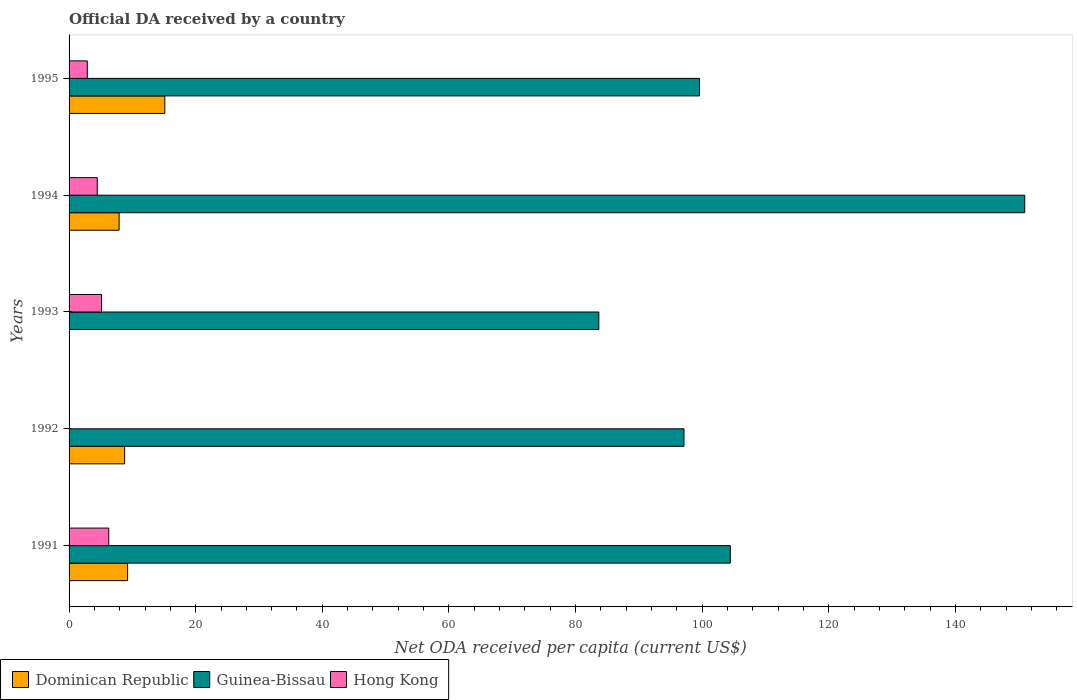How many groups of bars are there?
Your answer should be compact. 5. Are the number of bars on each tick of the Y-axis equal?
Give a very brief answer. No. What is the label of the 4th group of bars from the top?
Provide a short and direct response. 1992. In how many cases, is the number of bars for a given year not equal to the number of legend labels?
Offer a very short reply. 2. What is the ODA received in in Hong Kong in 1993?
Ensure brevity in your answer.  5.13. Across all years, what is the maximum ODA received in in Hong Kong?
Your answer should be very brief. 6.27. In which year was the ODA received in in Dominican Republic maximum?
Ensure brevity in your answer.  1995. What is the total ODA received in in Guinea-Bissau in the graph?
Provide a short and direct response. 535.78. What is the difference between the ODA received in in Dominican Republic in 1992 and that in 1995?
Keep it short and to the point. -6.34. What is the difference between the ODA received in in Hong Kong in 1992 and the ODA received in in Guinea-Bissau in 1993?
Offer a terse response. -83.68. What is the average ODA received in in Guinea-Bissau per year?
Keep it short and to the point. 107.16. In the year 1991, what is the difference between the ODA received in in Guinea-Bissau and ODA received in in Dominican Republic?
Give a very brief answer. 95.2. In how many years, is the ODA received in in Dominican Republic greater than 132 US$?
Ensure brevity in your answer.  0. What is the ratio of the ODA received in in Guinea-Bissau in 1992 to that in 1995?
Your answer should be very brief. 0.98. Is the ODA received in in Hong Kong in 1991 less than that in 1993?
Your answer should be compact. No. Is the difference between the ODA received in in Guinea-Bissau in 1994 and 1995 greater than the difference between the ODA received in in Dominican Republic in 1994 and 1995?
Give a very brief answer. Yes. What is the difference between the highest and the second highest ODA received in in Dominican Republic?
Give a very brief answer. 5.88. What is the difference between the highest and the lowest ODA received in in Dominican Republic?
Keep it short and to the point. 15.12. Is the sum of the ODA received in in Hong Kong in 1991 and 1995 greater than the maximum ODA received in in Guinea-Bissau across all years?
Offer a terse response. No. Where does the legend appear in the graph?
Provide a succinct answer. Bottom left. What is the title of the graph?
Provide a succinct answer. Official DA received by a country. Does "Pacific island small states" appear as one of the legend labels in the graph?
Your response must be concise. No. What is the label or title of the X-axis?
Your answer should be compact. Net ODA received per capita (current US$). What is the label or title of the Y-axis?
Keep it short and to the point. Years. What is the Net ODA received per capita (current US$) in Dominican Republic in 1991?
Provide a succinct answer. 9.24. What is the Net ODA received per capita (current US$) of Guinea-Bissau in 1991?
Make the answer very short. 104.44. What is the Net ODA received per capita (current US$) of Hong Kong in 1991?
Offer a very short reply. 6.27. What is the Net ODA received per capita (current US$) in Dominican Republic in 1992?
Provide a succinct answer. 8.78. What is the Net ODA received per capita (current US$) of Guinea-Bissau in 1992?
Make the answer very short. 97.13. What is the Net ODA received per capita (current US$) in Dominican Republic in 1993?
Your answer should be compact. 0. What is the Net ODA received per capita (current US$) of Guinea-Bissau in 1993?
Offer a terse response. 83.68. What is the Net ODA received per capita (current US$) of Hong Kong in 1993?
Keep it short and to the point. 5.13. What is the Net ODA received per capita (current US$) in Dominican Republic in 1994?
Provide a short and direct response. 7.9. What is the Net ODA received per capita (current US$) of Guinea-Bissau in 1994?
Keep it short and to the point. 150.95. What is the Net ODA received per capita (current US$) of Hong Kong in 1994?
Your response must be concise. 4.45. What is the Net ODA received per capita (current US$) in Dominican Republic in 1995?
Provide a succinct answer. 15.12. What is the Net ODA received per capita (current US$) in Guinea-Bissau in 1995?
Ensure brevity in your answer.  99.59. What is the Net ODA received per capita (current US$) in Hong Kong in 1995?
Your answer should be compact. 2.88. Across all years, what is the maximum Net ODA received per capita (current US$) of Dominican Republic?
Give a very brief answer. 15.12. Across all years, what is the maximum Net ODA received per capita (current US$) in Guinea-Bissau?
Ensure brevity in your answer.  150.95. Across all years, what is the maximum Net ODA received per capita (current US$) of Hong Kong?
Your answer should be very brief. 6.27. Across all years, what is the minimum Net ODA received per capita (current US$) of Guinea-Bissau?
Give a very brief answer. 83.68. What is the total Net ODA received per capita (current US$) in Dominican Republic in the graph?
Offer a terse response. 41.05. What is the total Net ODA received per capita (current US$) in Guinea-Bissau in the graph?
Your answer should be very brief. 535.78. What is the total Net ODA received per capita (current US$) in Hong Kong in the graph?
Ensure brevity in your answer.  18.73. What is the difference between the Net ODA received per capita (current US$) of Dominican Republic in 1991 and that in 1992?
Give a very brief answer. 0.46. What is the difference between the Net ODA received per capita (current US$) in Guinea-Bissau in 1991 and that in 1992?
Keep it short and to the point. 7.31. What is the difference between the Net ODA received per capita (current US$) in Guinea-Bissau in 1991 and that in 1993?
Make the answer very short. 20.77. What is the difference between the Net ODA received per capita (current US$) of Hong Kong in 1991 and that in 1993?
Offer a terse response. 1.14. What is the difference between the Net ODA received per capita (current US$) in Dominican Republic in 1991 and that in 1994?
Give a very brief answer. 1.34. What is the difference between the Net ODA received per capita (current US$) in Guinea-Bissau in 1991 and that in 1994?
Your answer should be very brief. -46.5. What is the difference between the Net ODA received per capita (current US$) in Hong Kong in 1991 and that in 1994?
Offer a terse response. 1.82. What is the difference between the Net ODA received per capita (current US$) in Dominican Republic in 1991 and that in 1995?
Keep it short and to the point. -5.88. What is the difference between the Net ODA received per capita (current US$) in Guinea-Bissau in 1991 and that in 1995?
Keep it short and to the point. 4.86. What is the difference between the Net ODA received per capita (current US$) in Hong Kong in 1991 and that in 1995?
Keep it short and to the point. 3.39. What is the difference between the Net ODA received per capita (current US$) of Guinea-Bissau in 1992 and that in 1993?
Your answer should be compact. 13.45. What is the difference between the Net ODA received per capita (current US$) of Dominican Republic in 1992 and that in 1994?
Keep it short and to the point. 0.88. What is the difference between the Net ODA received per capita (current US$) in Guinea-Bissau in 1992 and that in 1994?
Make the answer very short. -53.82. What is the difference between the Net ODA received per capita (current US$) in Dominican Republic in 1992 and that in 1995?
Make the answer very short. -6.34. What is the difference between the Net ODA received per capita (current US$) in Guinea-Bissau in 1992 and that in 1995?
Offer a very short reply. -2.46. What is the difference between the Net ODA received per capita (current US$) in Guinea-Bissau in 1993 and that in 1994?
Provide a succinct answer. -67.27. What is the difference between the Net ODA received per capita (current US$) of Hong Kong in 1993 and that in 1994?
Provide a succinct answer. 0.68. What is the difference between the Net ODA received per capita (current US$) in Guinea-Bissau in 1993 and that in 1995?
Your answer should be very brief. -15.91. What is the difference between the Net ODA received per capita (current US$) in Hong Kong in 1993 and that in 1995?
Provide a succinct answer. 2.25. What is the difference between the Net ODA received per capita (current US$) in Dominican Republic in 1994 and that in 1995?
Your response must be concise. -7.22. What is the difference between the Net ODA received per capita (current US$) in Guinea-Bissau in 1994 and that in 1995?
Keep it short and to the point. 51.36. What is the difference between the Net ODA received per capita (current US$) of Hong Kong in 1994 and that in 1995?
Your answer should be compact. 1.57. What is the difference between the Net ODA received per capita (current US$) of Dominican Republic in 1991 and the Net ODA received per capita (current US$) of Guinea-Bissau in 1992?
Ensure brevity in your answer.  -87.89. What is the difference between the Net ODA received per capita (current US$) in Dominican Republic in 1991 and the Net ODA received per capita (current US$) in Guinea-Bissau in 1993?
Offer a terse response. -74.43. What is the difference between the Net ODA received per capita (current US$) in Dominican Republic in 1991 and the Net ODA received per capita (current US$) in Hong Kong in 1993?
Make the answer very short. 4.11. What is the difference between the Net ODA received per capita (current US$) in Guinea-Bissau in 1991 and the Net ODA received per capita (current US$) in Hong Kong in 1993?
Ensure brevity in your answer.  99.31. What is the difference between the Net ODA received per capita (current US$) of Dominican Republic in 1991 and the Net ODA received per capita (current US$) of Guinea-Bissau in 1994?
Your answer should be very brief. -141.7. What is the difference between the Net ODA received per capita (current US$) in Dominican Republic in 1991 and the Net ODA received per capita (current US$) in Hong Kong in 1994?
Your response must be concise. 4.79. What is the difference between the Net ODA received per capita (current US$) of Guinea-Bissau in 1991 and the Net ODA received per capita (current US$) of Hong Kong in 1994?
Offer a very short reply. 99.99. What is the difference between the Net ODA received per capita (current US$) in Dominican Republic in 1991 and the Net ODA received per capita (current US$) in Guinea-Bissau in 1995?
Ensure brevity in your answer.  -90.34. What is the difference between the Net ODA received per capita (current US$) in Dominican Republic in 1991 and the Net ODA received per capita (current US$) in Hong Kong in 1995?
Your answer should be very brief. 6.36. What is the difference between the Net ODA received per capita (current US$) in Guinea-Bissau in 1991 and the Net ODA received per capita (current US$) in Hong Kong in 1995?
Your response must be concise. 101.56. What is the difference between the Net ODA received per capita (current US$) of Dominican Republic in 1992 and the Net ODA received per capita (current US$) of Guinea-Bissau in 1993?
Keep it short and to the point. -74.9. What is the difference between the Net ODA received per capita (current US$) in Dominican Republic in 1992 and the Net ODA received per capita (current US$) in Hong Kong in 1993?
Make the answer very short. 3.65. What is the difference between the Net ODA received per capita (current US$) of Guinea-Bissau in 1992 and the Net ODA received per capita (current US$) of Hong Kong in 1993?
Keep it short and to the point. 92. What is the difference between the Net ODA received per capita (current US$) in Dominican Republic in 1992 and the Net ODA received per capita (current US$) in Guinea-Bissau in 1994?
Your answer should be compact. -142.17. What is the difference between the Net ODA received per capita (current US$) in Dominican Republic in 1992 and the Net ODA received per capita (current US$) in Hong Kong in 1994?
Provide a succinct answer. 4.33. What is the difference between the Net ODA received per capita (current US$) of Guinea-Bissau in 1992 and the Net ODA received per capita (current US$) of Hong Kong in 1994?
Provide a succinct answer. 92.68. What is the difference between the Net ODA received per capita (current US$) of Dominican Republic in 1992 and the Net ODA received per capita (current US$) of Guinea-Bissau in 1995?
Ensure brevity in your answer.  -90.81. What is the difference between the Net ODA received per capita (current US$) in Dominican Republic in 1992 and the Net ODA received per capita (current US$) in Hong Kong in 1995?
Offer a terse response. 5.9. What is the difference between the Net ODA received per capita (current US$) of Guinea-Bissau in 1992 and the Net ODA received per capita (current US$) of Hong Kong in 1995?
Ensure brevity in your answer.  94.25. What is the difference between the Net ODA received per capita (current US$) in Guinea-Bissau in 1993 and the Net ODA received per capita (current US$) in Hong Kong in 1994?
Give a very brief answer. 79.22. What is the difference between the Net ODA received per capita (current US$) in Guinea-Bissau in 1993 and the Net ODA received per capita (current US$) in Hong Kong in 1995?
Offer a very short reply. 80.8. What is the difference between the Net ODA received per capita (current US$) of Dominican Republic in 1994 and the Net ODA received per capita (current US$) of Guinea-Bissau in 1995?
Offer a very short reply. -91.68. What is the difference between the Net ODA received per capita (current US$) of Dominican Republic in 1994 and the Net ODA received per capita (current US$) of Hong Kong in 1995?
Offer a very short reply. 5.02. What is the difference between the Net ODA received per capita (current US$) in Guinea-Bissau in 1994 and the Net ODA received per capita (current US$) in Hong Kong in 1995?
Your answer should be very brief. 148.07. What is the average Net ODA received per capita (current US$) of Dominican Republic per year?
Your answer should be very brief. 8.21. What is the average Net ODA received per capita (current US$) of Guinea-Bissau per year?
Provide a succinct answer. 107.16. What is the average Net ODA received per capita (current US$) of Hong Kong per year?
Your answer should be very brief. 3.75. In the year 1991, what is the difference between the Net ODA received per capita (current US$) in Dominican Republic and Net ODA received per capita (current US$) in Guinea-Bissau?
Ensure brevity in your answer.  -95.2. In the year 1991, what is the difference between the Net ODA received per capita (current US$) of Dominican Republic and Net ODA received per capita (current US$) of Hong Kong?
Keep it short and to the point. 2.97. In the year 1991, what is the difference between the Net ODA received per capita (current US$) of Guinea-Bissau and Net ODA received per capita (current US$) of Hong Kong?
Offer a very short reply. 98.17. In the year 1992, what is the difference between the Net ODA received per capita (current US$) in Dominican Republic and Net ODA received per capita (current US$) in Guinea-Bissau?
Your answer should be very brief. -88.35. In the year 1993, what is the difference between the Net ODA received per capita (current US$) of Guinea-Bissau and Net ODA received per capita (current US$) of Hong Kong?
Make the answer very short. 78.55. In the year 1994, what is the difference between the Net ODA received per capita (current US$) of Dominican Republic and Net ODA received per capita (current US$) of Guinea-Bissau?
Your answer should be very brief. -143.04. In the year 1994, what is the difference between the Net ODA received per capita (current US$) of Dominican Republic and Net ODA received per capita (current US$) of Hong Kong?
Provide a succinct answer. 3.45. In the year 1994, what is the difference between the Net ODA received per capita (current US$) of Guinea-Bissau and Net ODA received per capita (current US$) of Hong Kong?
Offer a very short reply. 146.49. In the year 1995, what is the difference between the Net ODA received per capita (current US$) of Dominican Republic and Net ODA received per capita (current US$) of Guinea-Bissau?
Provide a succinct answer. -84.46. In the year 1995, what is the difference between the Net ODA received per capita (current US$) in Dominican Republic and Net ODA received per capita (current US$) in Hong Kong?
Provide a short and direct response. 12.24. In the year 1995, what is the difference between the Net ODA received per capita (current US$) of Guinea-Bissau and Net ODA received per capita (current US$) of Hong Kong?
Ensure brevity in your answer.  96.71. What is the ratio of the Net ODA received per capita (current US$) of Dominican Republic in 1991 to that in 1992?
Offer a very short reply. 1.05. What is the ratio of the Net ODA received per capita (current US$) of Guinea-Bissau in 1991 to that in 1992?
Provide a short and direct response. 1.08. What is the ratio of the Net ODA received per capita (current US$) in Guinea-Bissau in 1991 to that in 1993?
Provide a succinct answer. 1.25. What is the ratio of the Net ODA received per capita (current US$) of Hong Kong in 1991 to that in 1993?
Offer a very short reply. 1.22. What is the ratio of the Net ODA received per capita (current US$) in Dominican Republic in 1991 to that in 1994?
Your answer should be very brief. 1.17. What is the ratio of the Net ODA received per capita (current US$) in Guinea-Bissau in 1991 to that in 1994?
Keep it short and to the point. 0.69. What is the ratio of the Net ODA received per capita (current US$) of Hong Kong in 1991 to that in 1994?
Your answer should be very brief. 1.41. What is the ratio of the Net ODA received per capita (current US$) in Dominican Republic in 1991 to that in 1995?
Give a very brief answer. 0.61. What is the ratio of the Net ODA received per capita (current US$) in Guinea-Bissau in 1991 to that in 1995?
Your answer should be compact. 1.05. What is the ratio of the Net ODA received per capita (current US$) in Hong Kong in 1991 to that in 1995?
Keep it short and to the point. 2.18. What is the ratio of the Net ODA received per capita (current US$) in Guinea-Bissau in 1992 to that in 1993?
Give a very brief answer. 1.16. What is the ratio of the Net ODA received per capita (current US$) in Guinea-Bissau in 1992 to that in 1994?
Keep it short and to the point. 0.64. What is the ratio of the Net ODA received per capita (current US$) of Dominican Republic in 1992 to that in 1995?
Your response must be concise. 0.58. What is the ratio of the Net ODA received per capita (current US$) in Guinea-Bissau in 1992 to that in 1995?
Give a very brief answer. 0.98. What is the ratio of the Net ODA received per capita (current US$) in Guinea-Bissau in 1993 to that in 1994?
Your answer should be very brief. 0.55. What is the ratio of the Net ODA received per capita (current US$) in Hong Kong in 1993 to that in 1994?
Offer a very short reply. 1.15. What is the ratio of the Net ODA received per capita (current US$) of Guinea-Bissau in 1993 to that in 1995?
Keep it short and to the point. 0.84. What is the ratio of the Net ODA received per capita (current US$) in Hong Kong in 1993 to that in 1995?
Your response must be concise. 1.78. What is the ratio of the Net ODA received per capita (current US$) of Dominican Republic in 1994 to that in 1995?
Keep it short and to the point. 0.52. What is the ratio of the Net ODA received per capita (current US$) of Guinea-Bissau in 1994 to that in 1995?
Provide a short and direct response. 1.52. What is the ratio of the Net ODA received per capita (current US$) in Hong Kong in 1994 to that in 1995?
Your answer should be compact. 1.55. What is the difference between the highest and the second highest Net ODA received per capita (current US$) of Dominican Republic?
Offer a terse response. 5.88. What is the difference between the highest and the second highest Net ODA received per capita (current US$) of Guinea-Bissau?
Keep it short and to the point. 46.5. What is the difference between the highest and the second highest Net ODA received per capita (current US$) of Hong Kong?
Provide a short and direct response. 1.14. What is the difference between the highest and the lowest Net ODA received per capita (current US$) in Dominican Republic?
Provide a succinct answer. 15.12. What is the difference between the highest and the lowest Net ODA received per capita (current US$) in Guinea-Bissau?
Keep it short and to the point. 67.27. What is the difference between the highest and the lowest Net ODA received per capita (current US$) in Hong Kong?
Offer a very short reply. 6.27. 